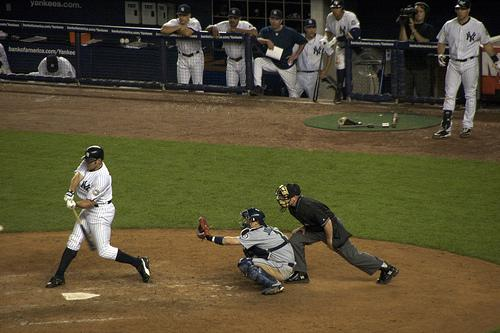Why does the kneeling man crouch low? catch ball 